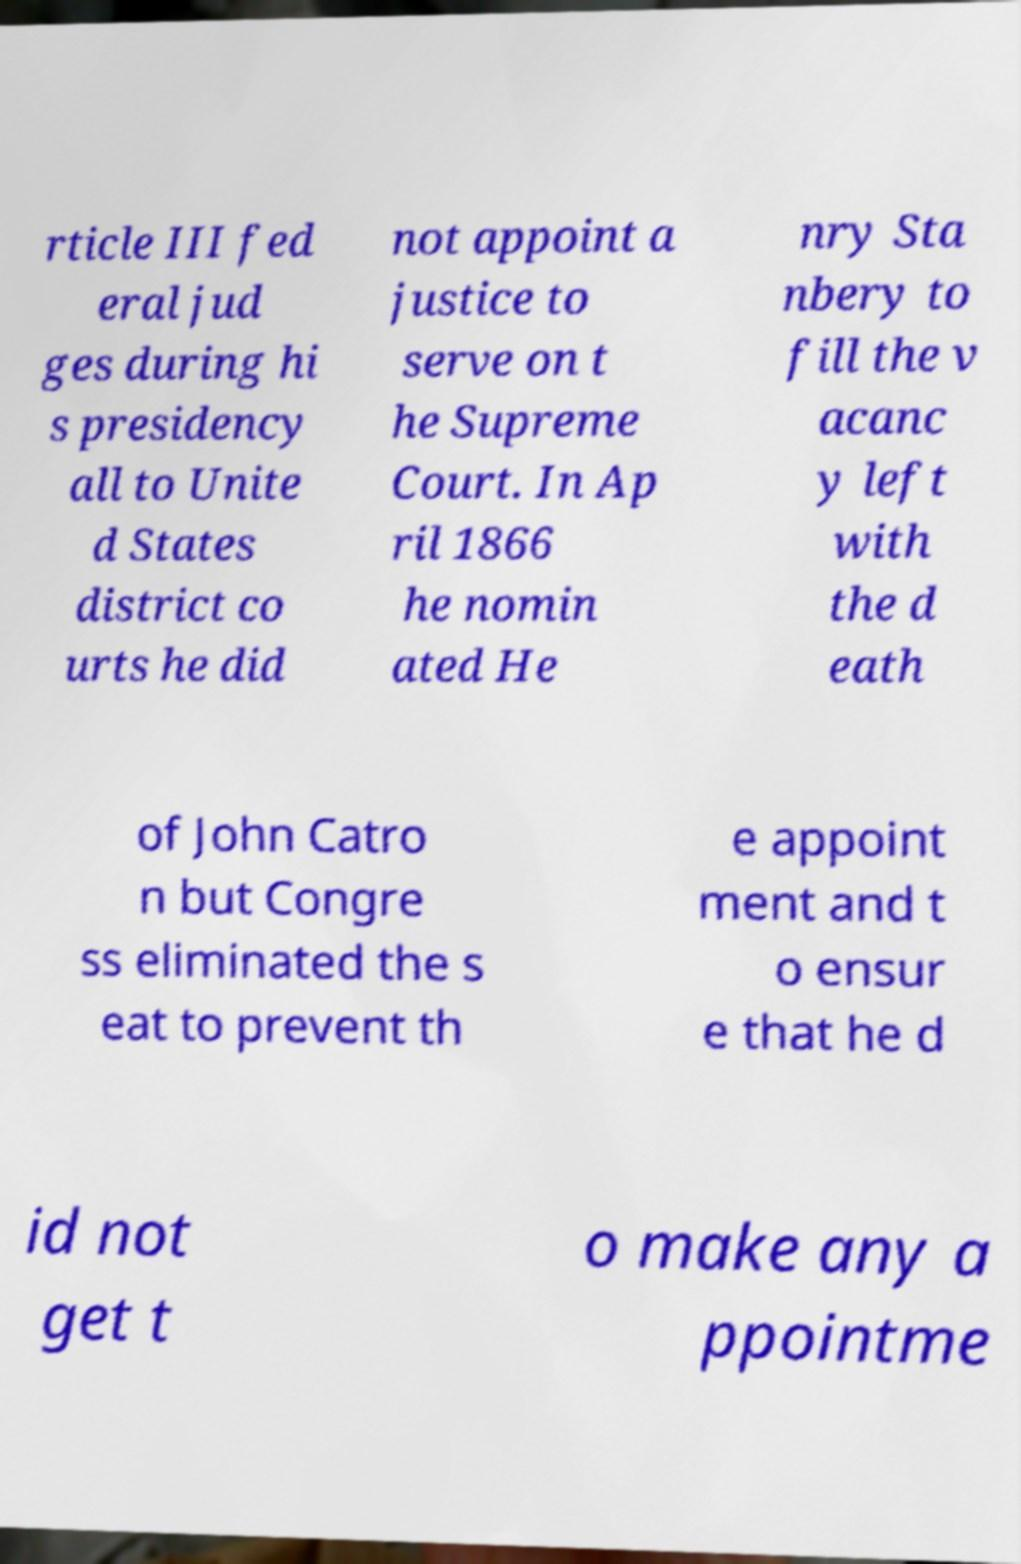Can you read and provide the text displayed in the image?This photo seems to have some interesting text. Can you extract and type it out for me? rticle III fed eral jud ges during hi s presidency all to Unite d States district co urts he did not appoint a justice to serve on t he Supreme Court. In Ap ril 1866 he nomin ated He nry Sta nbery to fill the v acanc y left with the d eath of John Catro n but Congre ss eliminated the s eat to prevent th e appoint ment and t o ensur e that he d id not get t o make any a ppointme 